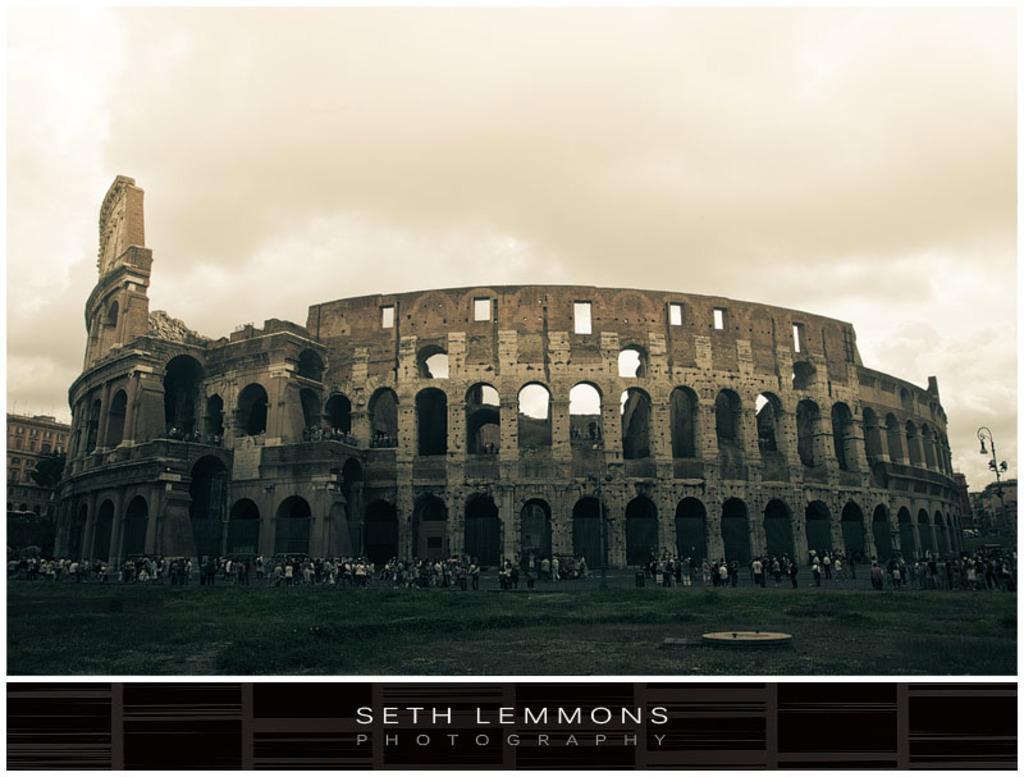Describe this image in one or two sentences. In this image we can see for, grass, poles, and people. In the background there is sky with clouds. At the bottom of the image we can see something is written on it. 